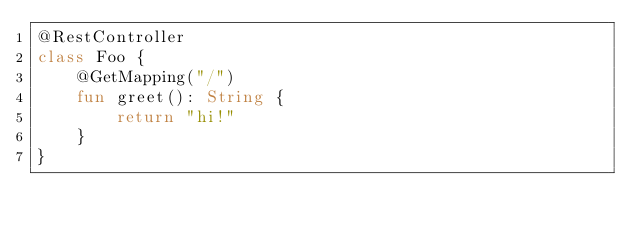<code> <loc_0><loc_0><loc_500><loc_500><_Kotlin_>@RestController
class Foo {
	@GetMapping("/")
	fun greet(): String {
		return "hi!"
	}
}
</code> 